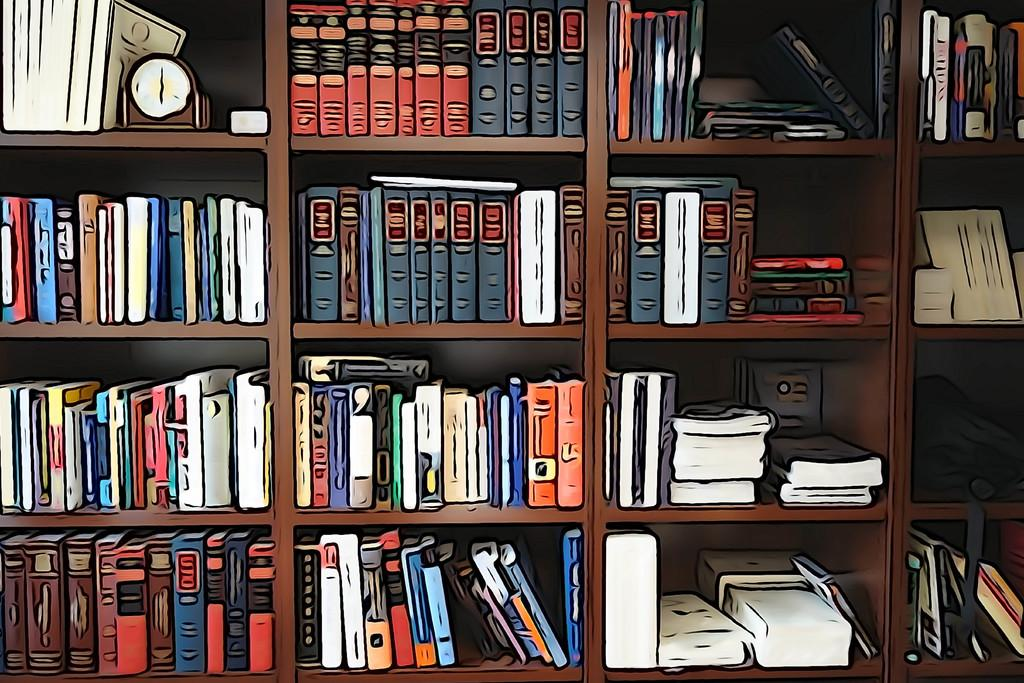What type of editing has been done to the image? The image is edited, but the specific type of editing is not mentioned in the facts. What objects can be seen on the shelves in the image? There are books and a clock on wooden shelves in the image. What type of object is the clock? The clock is an object that can be seen in the image. What type of pancake is being invented in the image? There is no pancake or invention process present in the image. What type of wave can be seen in the image? There is no wave present in the image. 